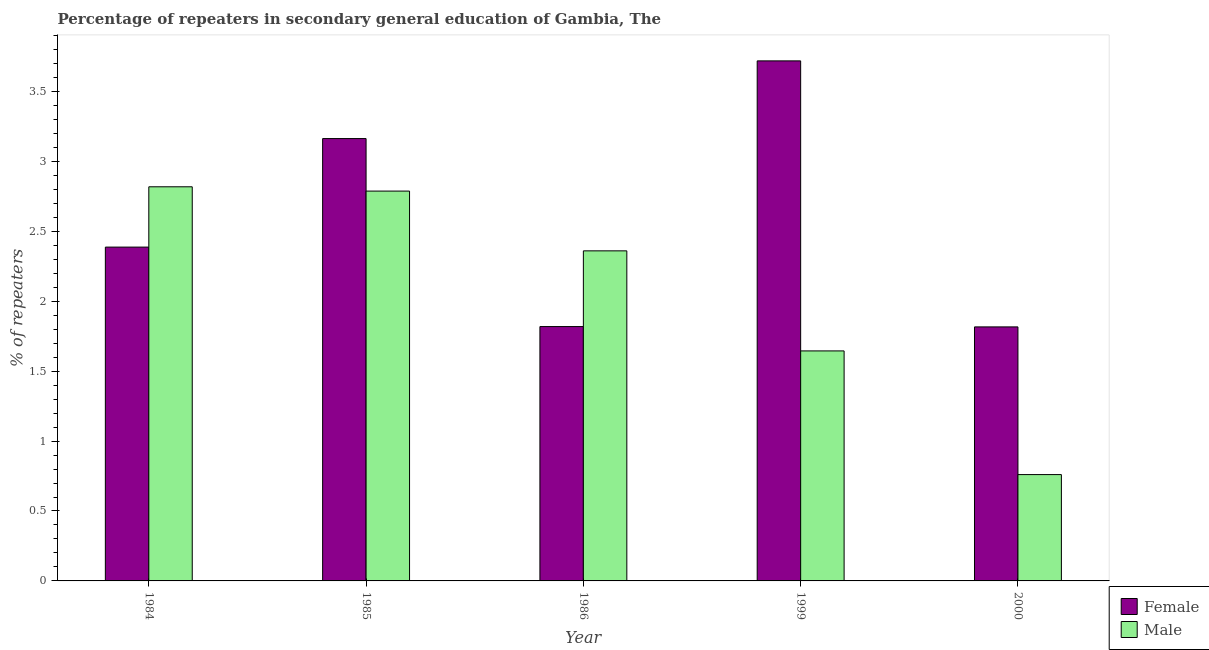How many different coloured bars are there?
Give a very brief answer. 2. How many bars are there on the 5th tick from the left?
Your response must be concise. 2. How many bars are there on the 2nd tick from the right?
Offer a very short reply. 2. In how many cases, is the number of bars for a given year not equal to the number of legend labels?
Your response must be concise. 0. What is the percentage of female repeaters in 1999?
Your answer should be compact. 3.72. Across all years, what is the maximum percentage of female repeaters?
Ensure brevity in your answer.  3.72. Across all years, what is the minimum percentage of female repeaters?
Your answer should be very brief. 1.82. What is the total percentage of female repeaters in the graph?
Offer a terse response. 12.9. What is the difference between the percentage of female repeaters in 1984 and that in 1999?
Ensure brevity in your answer.  -1.33. What is the difference between the percentage of female repeaters in 2000 and the percentage of male repeaters in 1999?
Provide a short and direct response. -1.9. What is the average percentage of male repeaters per year?
Keep it short and to the point. 2.07. In how many years, is the percentage of female repeaters greater than 0.5 %?
Give a very brief answer. 5. What is the ratio of the percentage of male repeaters in 1986 to that in 2000?
Your answer should be compact. 3.1. Is the percentage of female repeaters in 1985 less than that in 1986?
Provide a succinct answer. No. Is the difference between the percentage of female repeaters in 1985 and 1999 greater than the difference between the percentage of male repeaters in 1985 and 1999?
Provide a short and direct response. No. What is the difference between the highest and the second highest percentage of female repeaters?
Your answer should be compact. 0.56. What is the difference between the highest and the lowest percentage of female repeaters?
Offer a very short reply. 1.9. In how many years, is the percentage of female repeaters greater than the average percentage of female repeaters taken over all years?
Provide a short and direct response. 2. What does the 2nd bar from the right in 1985 represents?
Make the answer very short. Female. Are all the bars in the graph horizontal?
Keep it short and to the point. No. How many years are there in the graph?
Make the answer very short. 5. What is the difference between two consecutive major ticks on the Y-axis?
Make the answer very short. 0.5. Are the values on the major ticks of Y-axis written in scientific E-notation?
Ensure brevity in your answer.  No. Where does the legend appear in the graph?
Keep it short and to the point. Bottom right. How many legend labels are there?
Your answer should be very brief. 2. How are the legend labels stacked?
Your response must be concise. Vertical. What is the title of the graph?
Make the answer very short. Percentage of repeaters in secondary general education of Gambia, The. What is the label or title of the X-axis?
Your answer should be very brief. Year. What is the label or title of the Y-axis?
Keep it short and to the point. % of repeaters. What is the % of repeaters of Female in 1984?
Offer a very short reply. 2.39. What is the % of repeaters of Male in 1984?
Provide a short and direct response. 2.82. What is the % of repeaters in Female in 1985?
Provide a succinct answer. 3.16. What is the % of repeaters of Male in 1985?
Offer a very short reply. 2.79. What is the % of repeaters in Female in 1986?
Give a very brief answer. 1.82. What is the % of repeaters of Male in 1986?
Give a very brief answer. 2.36. What is the % of repeaters of Female in 1999?
Provide a succinct answer. 3.72. What is the % of repeaters of Male in 1999?
Offer a terse response. 1.64. What is the % of repeaters of Female in 2000?
Your answer should be compact. 1.82. What is the % of repeaters of Male in 2000?
Your answer should be compact. 0.76. Across all years, what is the maximum % of repeaters in Female?
Your answer should be very brief. 3.72. Across all years, what is the maximum % of repeaters in Male?
Offer a terse response. 2.82. Across all years, what is the minimum % of repeaters in Female?
Provide a short and direct response. 1.82. Across all years, what is the minimum % of repeaters in Male?
Keep it short and to the point. 0.76. What is the total % of repeaters of Female in the graph?
Provide a succinct answer. 12.9. What is the total % of repeaters of Male in the graph?
Your response must be concise. 10.37. What is the difference between the % of repeaters of Female in 1984 and that in 1985?
Keep it short and to the point. -0.78. What is the difference between the % of repeaters of Male in 1984 and that in 1985?
Your answer should be compact. 0.03. What is the difference between the % of repeaters of Female in 1984 and that in 1986?
Provide a short and direct response. 0.57. What is the difference between the % of repeaters in Male in 1984 and that in 1986?
Offer a very short reply. 0.46. What is the difference between the % of repeaters in Female in 1984 and that in 1999?
Offer a very short reply. -1.33. What is the difference between the % of repeaters in Male in 1984 and that in 1999?
Provide a short and direct response. 1.17. What is the difference between the % of repeaters in Female in 1984 and that in 2000?
Provide a short and direct response. 0.57. What is the difference between the % of repeaters in Male in 1984 and that in 2000?
Make the answer very short. 2.06. What is the difference between the % of repeaters of Female in 1985 and that in 1986?
Provide a succinct answer. 1.34. What is the difference between the % of repeaters in Male in 1985 and that in 1986?
Provide a short and direct response. 0.43. What is the difference between the % of repeaters in Female in 1985 and that in 1999?
Offer a very short reply. -0.56. What is the difference between the % of repeaters of Male in 1985 and that in 1999?
Offer a terse response. 1.14. What is the difference between the % of repeaters in Female in 1985 and that in 2000?
Offer a very short reply. 1.35. What is the difference between the % of repeaters of Male in 1985 and that in 2000?
Your response must be concise. 2.03. What is the difference between the % of repeaters in Female in 1986 and that in 1999?
Provide a succinct answer. -1.9. What is the difference between the % of repeaters in Male in 1986 and that in 1999?
Your answer should be very brief. 0.72. What is the difference between the % of repeaters of Female in 1986 and that in 2000?
Provide a succinct answer. 0. What is the difference between the % of repeaters of Male in 1986 and that in 2000?
Make the answer very short. 1.6. What is the difference between the % of repeaters in Female in 1999 and that in 2000?
Provide a succinct answer. 1.9. What is the difference between the % of repeaters of Male in 1999 and that in 2000?
Your answer should be very brief. 0.88. What is the difference between the % of repeaters in Female in 1984 and the % of repeaters in Male in 1985?
Give a very brief answer. -0.4. What is the difference between the % of repeaters in Female in 1984 and the % of repeaters in Male in 1986?
Your answer should be very brief. 0.03. What is the difference between the % of repeaters of Female in 1984 and the % of repeaters of Male in 1999?
Keep it short and to the point. 0.74. What is the difference between the % of repeaters of Female in 1984 and the % of repeaters of Male in 2000?
Ensure brevity in your answer.  1.63. What is the difference between the % of repeaters of Female in 1985 and the % of repeaters of Male in 1986?
Your answer should be compact. 0.8. What is the difference between the % of repeaters in Female in 1985 and the % of repeaters in Male in 1999?
Make the answer very short. 1.52. What is the difference between the % of repeaters of Female in 1985 and the % of repeaters of Male in 2000?
Provide a short and direct response. 2.4. What is the difference between the % of repeaters in Female in 1986 and the % of repeaters in Male in 1999?
Your answer should be compact. 0.17. What is the difference between the % of repeaters of Female in 1986 and the % of repeaters of Male in 2000?
Make the answer very short. 1.06. What is the difference between the % of repeaters in Female in 1999 and the % of repeaters in Male in 2000?
Provide a succinct answer. 2.96. What is the average % of repeaters of Female per year?
Make the answer very short. 2.58. What is the average % of repeaters in Male per year?
Your answer should be compact. 2.07. In the year 1984, what is the difference between the % of repeaters of Female and % of repeaters of Male?
Keep it short and to the point. -0.43. In the year 1985, what is the difference between the % of repeaters in Female and % of repeaters in Male?
Make the answer very short. 0.38. In the year 1986, what is the difference between the % of repeaters of Female and % of repeaters of Male?
Provide a succinct answer. -0.54. In the year 1999, what is the difference between the % of repeaters in Female and % of repeaters in Male?
Your answer should be compact. 2.07. In the year 2000, what is the difference between the % of repeaters of Female and % of repeaters of Male?
Provide a short and direct response. 1.06. What is the ratio of the % of repeaters in Female in 1984 to that in 1985?
Make the answer very short. 0.75. What is the ratio of the % of repeaters in Male in 1984 to that in 1985?
Make the answer very short. 1.01. What is the ratio of the % of repeaters of Female in 1984 to that in 1986?
Your answer should be very brief. 1.31. What is the ratio of the % of repeaters of Male in 1984 to that in 1986?
Offer a very short reply. 1.19. What is the ratio of the % of repeaters of Female in 1984 to that in 1999?
Make the answer very short. 0.64. What is the ratio of the % of repeaters in Male in 1984 to that in 1999?
Provide a short and direct response. 1.71. What is the ratio of the % of repeaters of Female in 1984 to that in 2000?
Your answer should be very brief. 1.31. What is the ratio of the % of repeaters in Male in 1984 to that in 2000?
Make the answer very short. 3.71. What is the ratio of the % of repeaters of Female in 1985 to that in 1986?
Keep it short and to the point. 1.74. What is the ratio of the % of repeaters in Male in 1985 to that in 1986?
Make the answer very short. 1.18. What is the ratio of the % of repeaters of Female in 1985 to that in 1999?
Your answer should be very brief. 0.85. What is the ratio of the % of repeaters of Male in 1985 to that in 1999?
Provide a succinct answer. 1.69. What is the ratio of the % of repeaters of Female in 1985 to that in 2000?
Ensure brevity in your answer.  1.74. What is the ratio of the % of repeaters of Male in 1985 to that in 2000?
Keep it short and to the point. 3.67. What is the ratio of the % of repeaters of Female in 1986 to that in 1999?
Offer a terse response. 0.49. What is the ratio of the % of repeaters in Male in 1986 to that in 1999?
Your answer should be very brief. 1.44. What is the ratio of the % of repeaters of Female in 1986 to that in 2000?
Give a very brief answer. 1. What is the ratio of the % of repeaters of Male in 1986 to that in 2000?
Make the answer very short. 3.1. What is the ratio of the % of repeaters of Female in 1999 to that in 2000?
Your answer should be compact. 2.05. What is the ratio of the % of repeaters in Male in 1999 to that in 2000?
Your answer should be very brief. 2.16. What is the difference between the highest and the second highest % of repeaters of Female?
Offer a very short reply. 0.56. What is the difference between the highest and the second highest % of repeaters in Male?
Provide a short and direct response. 0.03. What is the difference between the highest and the lowest % of repeaters of Female?
Ensure brevity in your answer.  1.9. What is the difference between the highest and the lowest % of repeaters of Male?
Offer a very short reply. 2.06. 